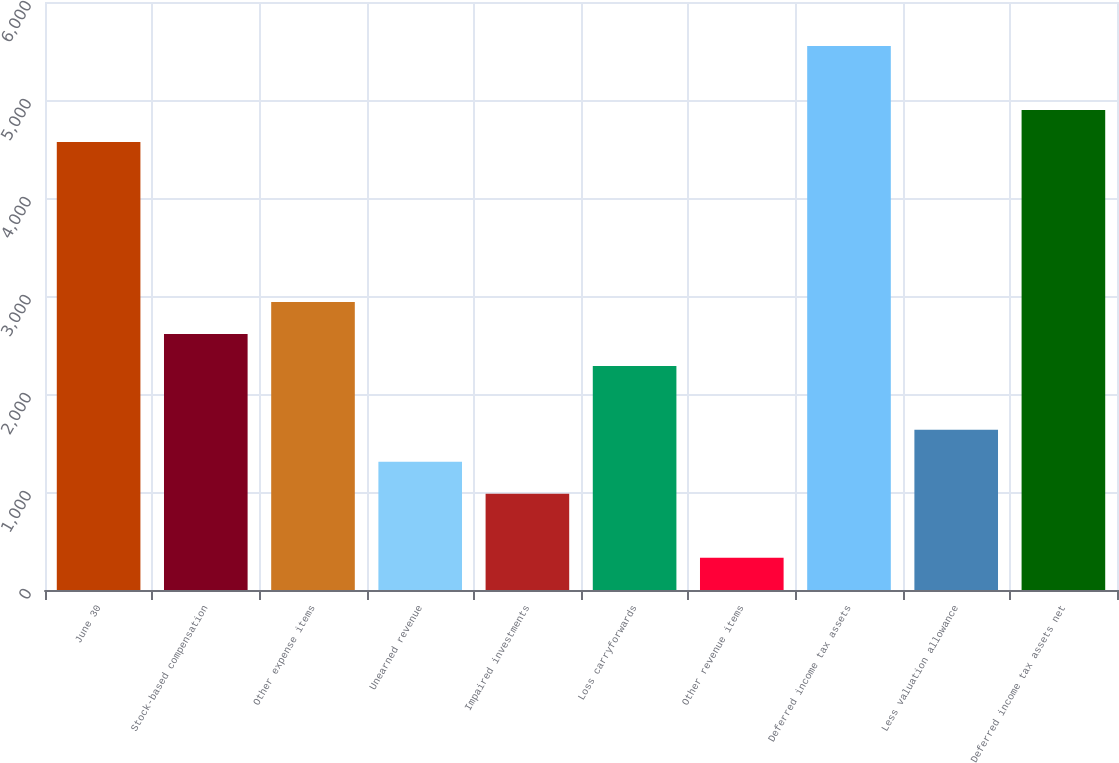<chart> <loc_0><loc_0><loc_500><loc_500><bar_chart><fcel>June 30<fcel>Stock-based compensation<fcel>Other expense items<fcel>Unearned revenue<fcel>Impaired investments<fcel>Loss carryforwards<fcel>Other revenue items<fcel>Deferred income tax assets<fcel>Less valuation allowance<fcel>Deferred income tax assets net<nl><fcel>4571.6<fcel>2613.2<fcel>2939.6<fcel>1307.6<fcel>981.2<fcel>2286.8<fcel>328.4<fcel>5550.8<fcel>1634<fcel>4898<nl></chart> 